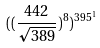<formula> <loc_0><loc_0><loc_500><loc_500>( ( \frac { 4 4 2 } { \sqrt { 3 8 9 } } ) ^ { 8 } ) ^ { 3 9 5 ^ { 1 } }</formula> 